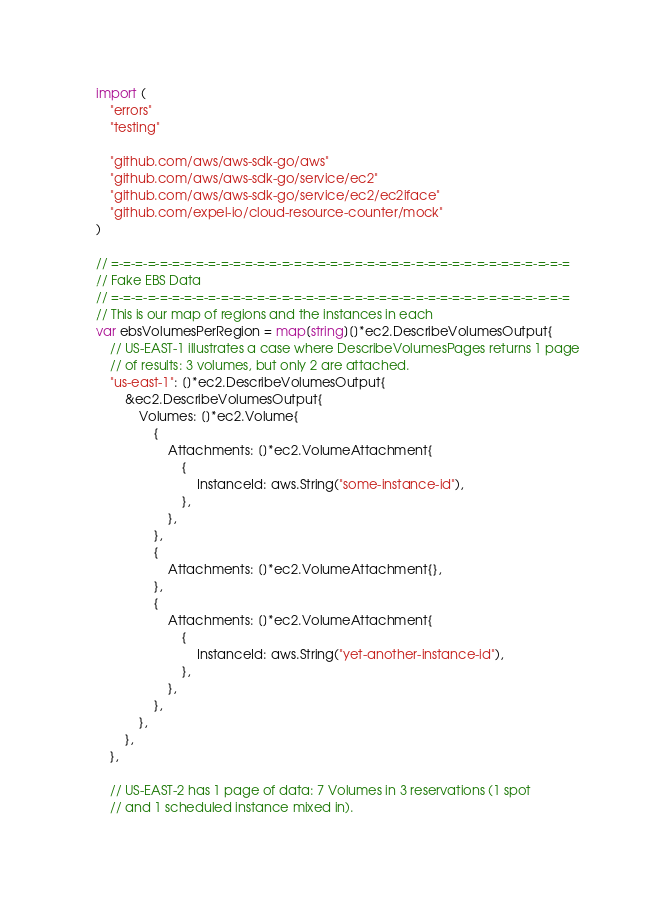<code> <loc_0><loc_0><loc_500><loc_500><_Go_>
import (
	"errors"
	"testing"

	"github.com/aws/aws-sdk-go/aws"
	"github.com/aws/aws-sdk-go/service/ec2"
	"github.com/aws/aws-sdk-go/service/ec2/ec2iface"
	"github.com/expel-io/cloud-resource-counter/mock"
)

// =-=-=-=-=-=-=-=-=-=-=-=-=-=-=-=-=-=-=-=-=-=-=-=-=-=-=-=-=-=-=-=-=-=-=-=-=-=
// Fake EBS Data
// =-=-=-=-=-=-=-=-=-=-=-=-=-=-=-=-=-=-=-=-=-=-=-=-=-=-=-=-=-=-=-=-=-=-=-=-=-=
// This is our map of regions and the instances in each
var ebsVolumesPerRegion = map[string][]*ec2.DescribeVolumesOutput{
	// US-EAST-1 illustrates a case where DescribeVolumesPages returns 1 page
	// of results: 3 volumes, but only 2 are attached.
	"us-east-1": []*ec2.DescribeVolumesOutput{
		&ec2.DescribeVolumesOutput{
			Volumes: []*ec2.Volume{
				{
					Attachments: []*ec2.VolumeAttachment{
						{
							InstanceId: aws.String("some-instance-id"),
						},
					},
				},
				{
					Attachments: []*ec2.VolumeAttachment{},
				},
				{
					Attachments: []*ec2.VolumeAttachment{
						{
							InstanceId: aws.String("yet-another-instance-id"),
						},
					},
				},
			},
		},
	},

	// US-EAST-2 has 1 page of data: 7 Volumes in 3 reservations (1 spot
	// and 1 scheduled instance mixed in).</code> 